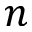Convert formula to latex. <formula><loc_0><loc_0><loc_500><loc_500>n</formula> 